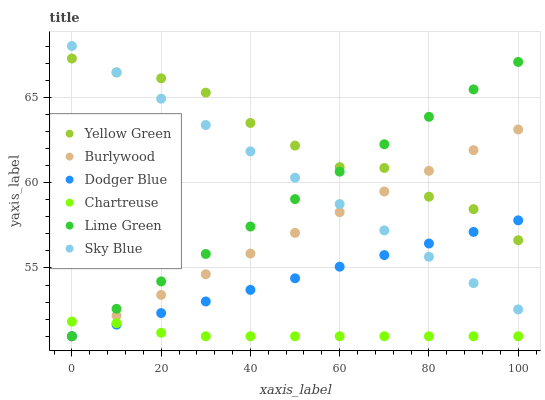Does Chartreuse have the minimum area under the curve?
Answer yes or no. Yes. Does Yellow Green have the maximum area under the curve?
Answer yes or no. Yes. Does Burlywood have the minimum area under the curve?
Answer yes or no. No. Does Burlywood have the maximum area under the curve?
Answer yes or no. No. Is Dodger Blue the smoothest?
Answer yes or no. Yes. Is Yellow Green the roughest?
Answer yes or no. Yes. Is Burlywood the smoothest?
Answer yes or no. No. Is Burlywood the roughest?
Answer yes or no. No. Does Burlywood have the lowest value?
Answer yes or no. Yes. Does Sky Blue have the lowest value?
Answer yes or no. No. Does Sky Blue have the highest value?
Answer yes or no. Yes. Does Burlywood have the highest value?
Answer yes or no. No. Is Chartreuse less than Yellow Green?
Answer yes or no. Yes. Is Yellow Green greater than Chartreuse?
Answer yes or no. Yes. Does Sky Blue intersect Yellow Green?
Answer yes or no. Yes. Is Sky Blue less than Yellow Green?
Answer yes or no. No. Is Sky Blue greater than Yellow Green?
Answer yes or no. No. Does Chartreuse intersect Yellow Green?
Answer yes or no. No. 